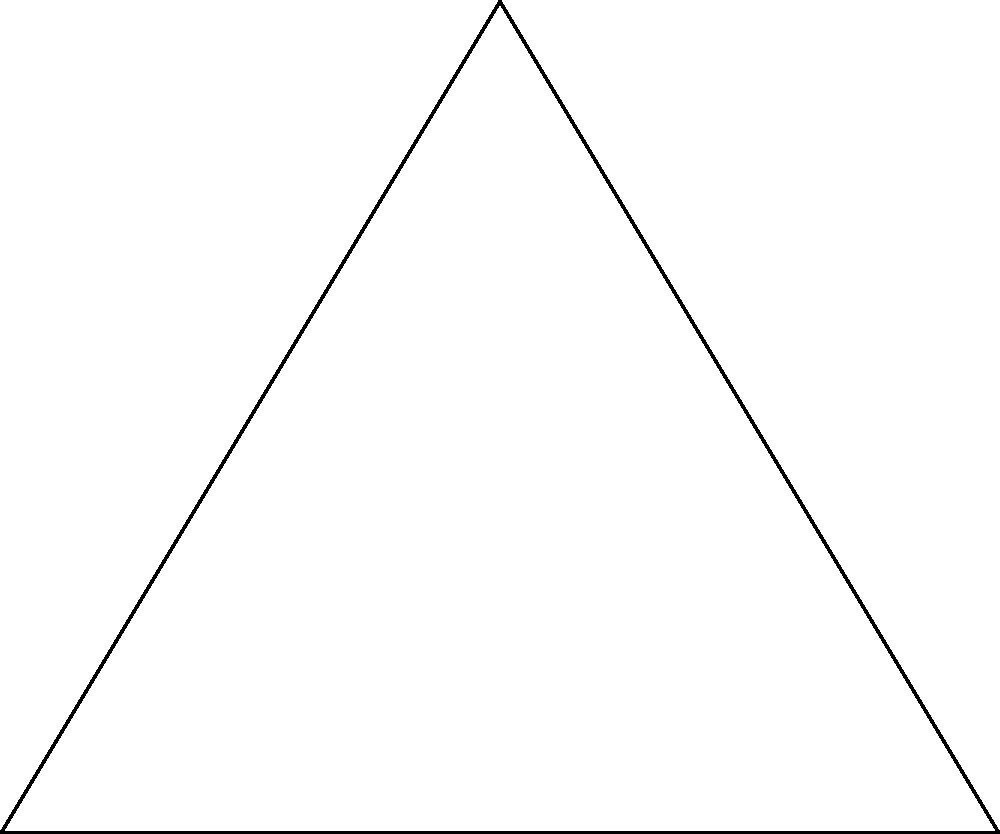In the Bird Streets neighborhood, a triangular plot of land is represented by triangle ABC. If the sides of the triangle are 6 cm, 8 cm, and 10 cm, what is the radius of the largest circular fountain that can be placed in the center of this plot? To find the radius of the inscribed circle (incircle) in a triangle, we can use the following steps:

1) First, we need to calculate the semi-perimeter (s) of the triangle:
   $s = \frac{a + b + c}{2}$ where a, b, and c are the side lengths
   $s = \frac{6 + 8 + 10}{2} = 12$ cm

2) Next, we use the formula for the area (A) of a triangle using the semi-perimeter:
   $A = \sqrt{s(s-a)(s-b)(s-c)}$
   $A = \sqrt{12(12-6)(12-8)(12-10)}$
   $A = \sqrt{12 \cdot 6 \cdot 4 \cdot 2}$
   $A = \sqrt{576} = 24$ sq cm

3) Now, we can use the formula for the radius (r) of the incircle:
   $r = \frac{A}{s}$

4) Substituting our values:
   $r = \frac{24}{12} = 2$ cm

Therefore, the radius of the largest circular fountain that can be placed in the center of this triangular plot is 2 cm.
Answer: 2 cm 